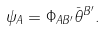Convert formula to latex. <formula><loc_0><loc_0><loc_500><loc_500>\psi _ { A } = \Phi _ { A B ^ { \prime } } \bar { \theta } ^ { B ^ { \prime } } .</formula> 